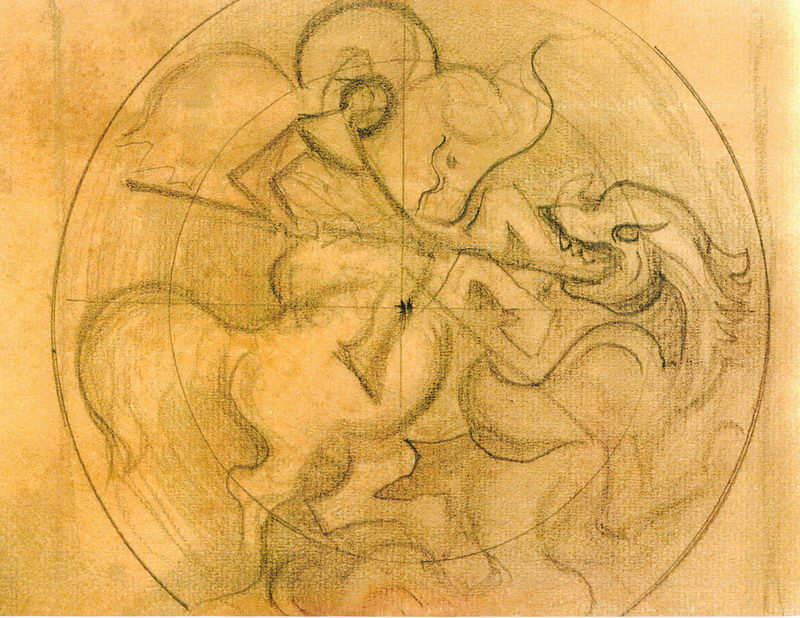What era or style does this artwork represent, and how can you tell? The artwork represents a Renaissance style, characterized by its attention to human anatomy, movement, and emotion. The drawing technique with its dynamic poses and detailed rendering of muscles and expressions aligns with Renaissance principles that focus heavily on the lifelike depiction of the human body. 